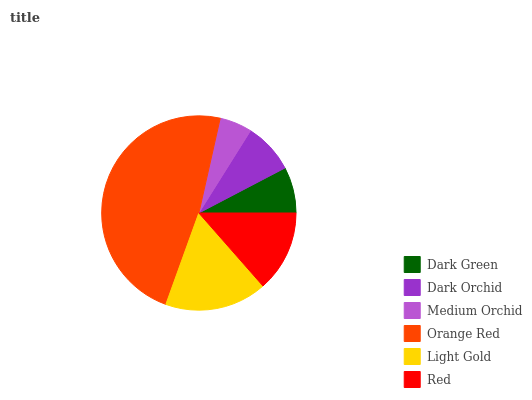Is Medium Orchid the minimum?
Answer yes or no. Yes. Is Orange Red the maximum?
Answer yes or no. Yes. Is Dark Orchid the minimum?
Answer yes or no. No. Is Dark Orchid the maximum?
Answer yes or no. No. Is Dark Orchid greater than Dark Green?
Answer yes or no. Yes. Is Dark Green less than Dark Orchid?
Answer yes or no. Yes. Is Dark Green greater than Dark Orchid?
Answer yes or no. No. Is Dark Orchid less than Dark Green?
Answer yes or no. No. Is Red the high median?
Answer yes or no. Yes. Is Dark Orchid the low median?
Answer yes or no. Yes. Is Medium Orchid the high median?
Answer yes or no. No. Is Light Gold the low median?
Answer yes or no. No. 